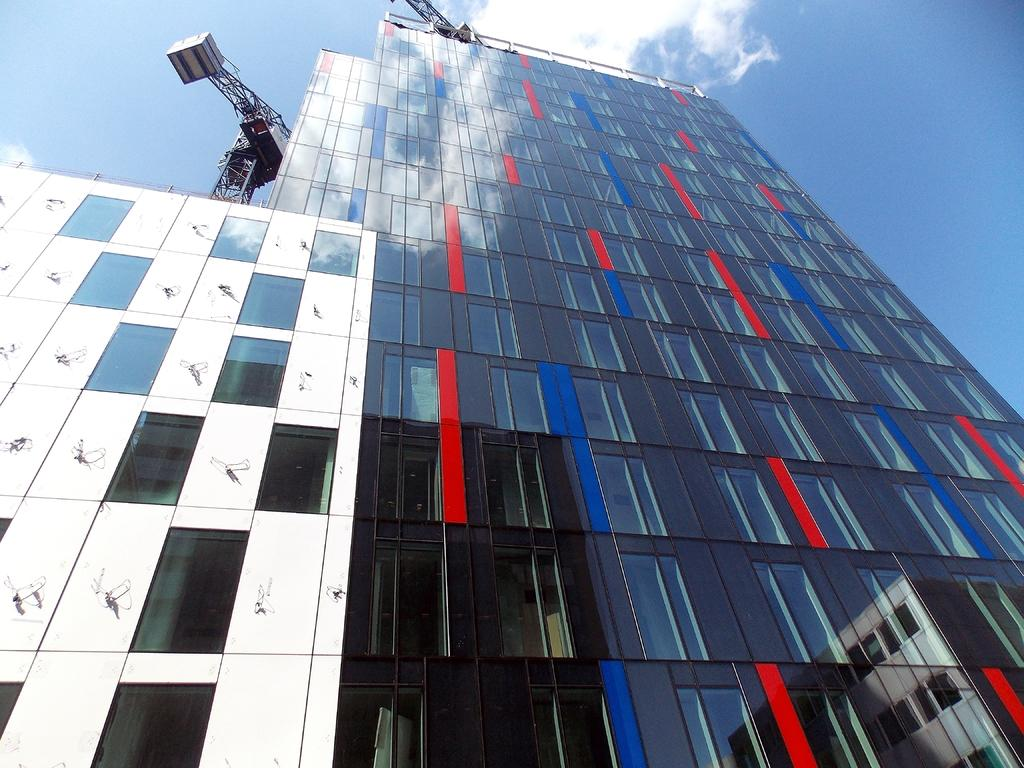What type of building is shown in the image? There is a building with glass windows in the image. What is on top of the building? There is a crane on top of the building. What is the crane doing or holding? The crane has an object attached to it. What can be seen in the background of the image? The sky is visible in the background of the image. How many pigs are visible in the image? There are no pigs present in the image. What theory is being discussed in the image? There is no discussion or reference to any theory in the image. 